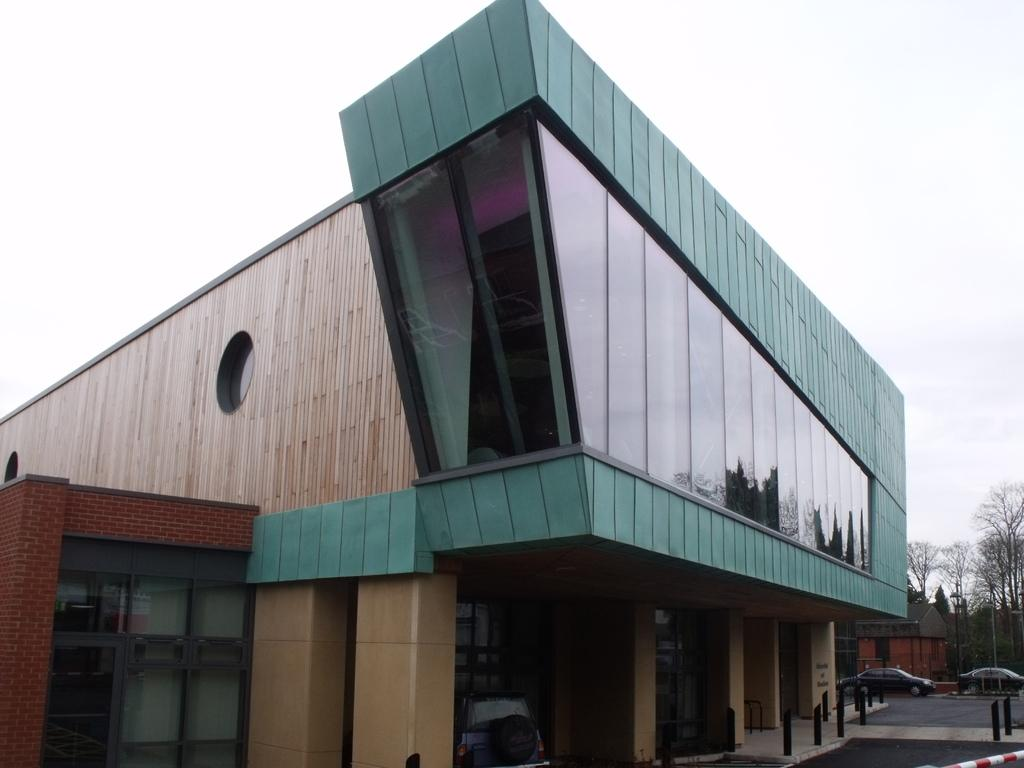What type of structure is present in the image? There is a building in the image. What feature can be observed on the building? The building has glass windows. What type of vegetation is visible in the image? There are trees in the image. What else can be seen moving in the image? There are vehicles in the image. What is visible at the top of the image? The sky is visible at the top of the image. What grade of toothbrush is recommended for the building in the image? There is no toothbrush present in the image, and therefore no grade can be recommended. 